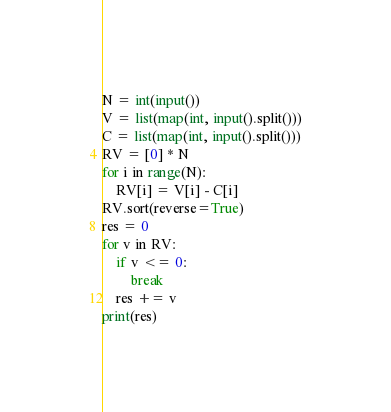<code> <loc_0><loc_0><loc_500><loc_500><_Python_>N = int(input())
V = list(map(int, input().split()))
C = list(map(int, input().split()))
RV = [0] * N
for i in range(N):
    RV[i] = V[i] - C[i]
RV.sort(reverse=True)
res = 0
for v in RV:
    if v <= 0:
        break
    res += v
print(res)
</code> 